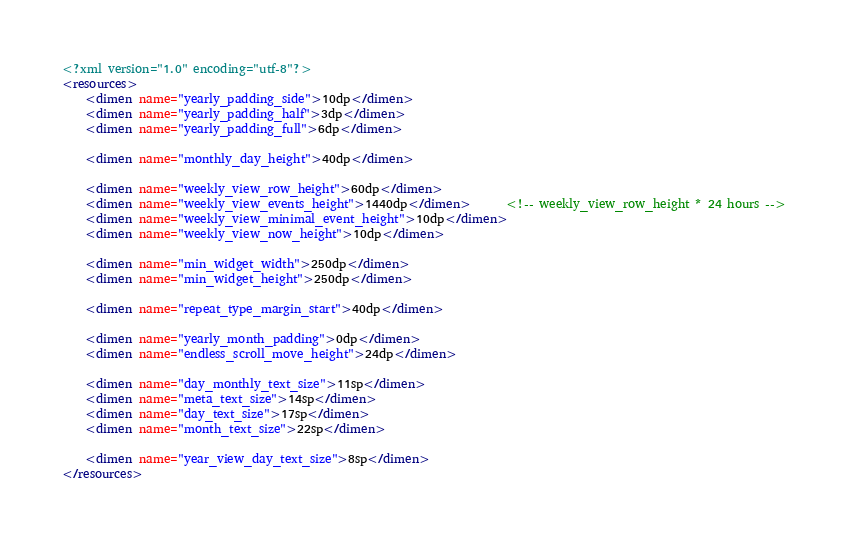<code> <loc_0><loc_0><loc_500><loc_500><_XML_><?xml version="1.0" encoding="utf-8"?>
<resources>
    <dimen name="yearly_padding_side">10dp</dimen>
    <dimen name="yearly_padding_half">3dp</dimen>
    <dimen name="yearly_padding_full">6dp</dimen>

    <dimen name="monthly_day_height">40dp</dimen>

    <dimen name="weekly_view_row_height">60dp</dimen>
    <dimen name="weekly_view_events_height">1440dp</dimen>      <!-- weekly_view_row_height * 24 hours -->
    <dimen name="weekly_view_minimal_event_height">10dp</dimen>
    <dimen name="weekly_view_now_height">10dp</dimen>

    <dimen name="min_widget_width">250dp</dimen>
    <dimen name="min_widget_height">250dp</dimen>

    <dimen name="repeat_type_margin_start">40dp</dimen>

    <dimen name="yearly_month_padding">0dp</dimen>
    <dimen name="endless_scroll_move_height">24dp</dimen>

    <dimen name="day_monthly_text_size">11sp</dimen>
    <dimen name="meta_text_size">14sp</dimen>
    <dimen name="day_text_size">17sp</dimen>
    <dimen name="month_text_size">22sp</dimen>

    <dimen name="year_view_day_text_size">8sp</dimen>
</resources>
</code> 